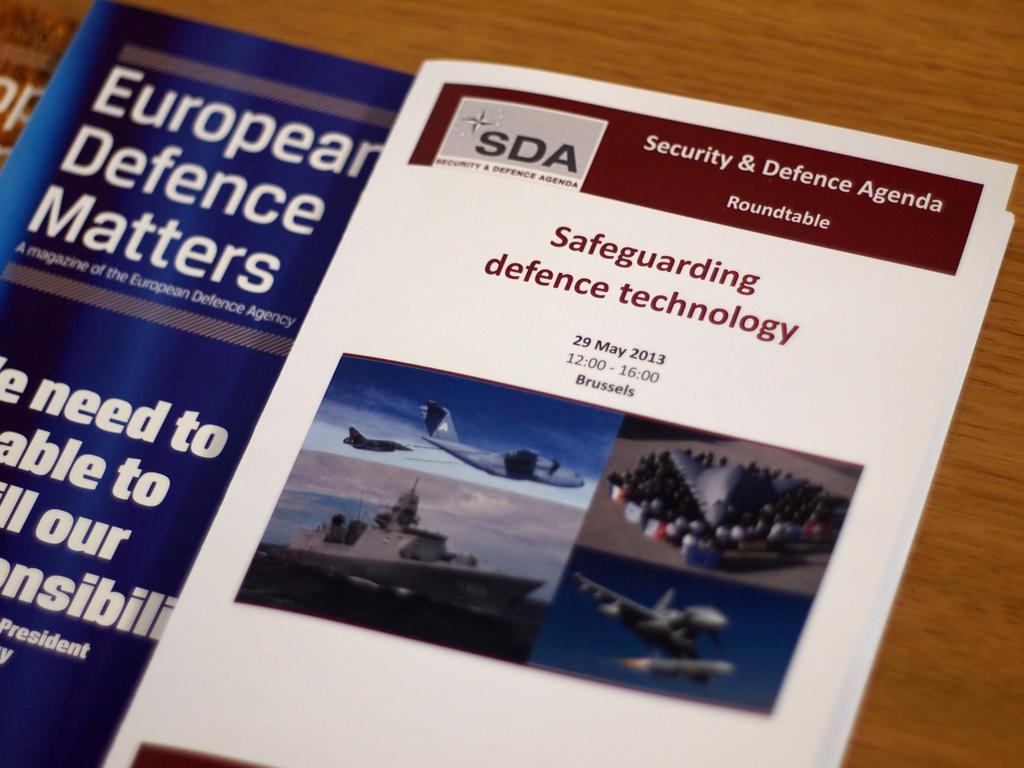What year was this roundtable held?
Provide a succinct answer. 2013. 